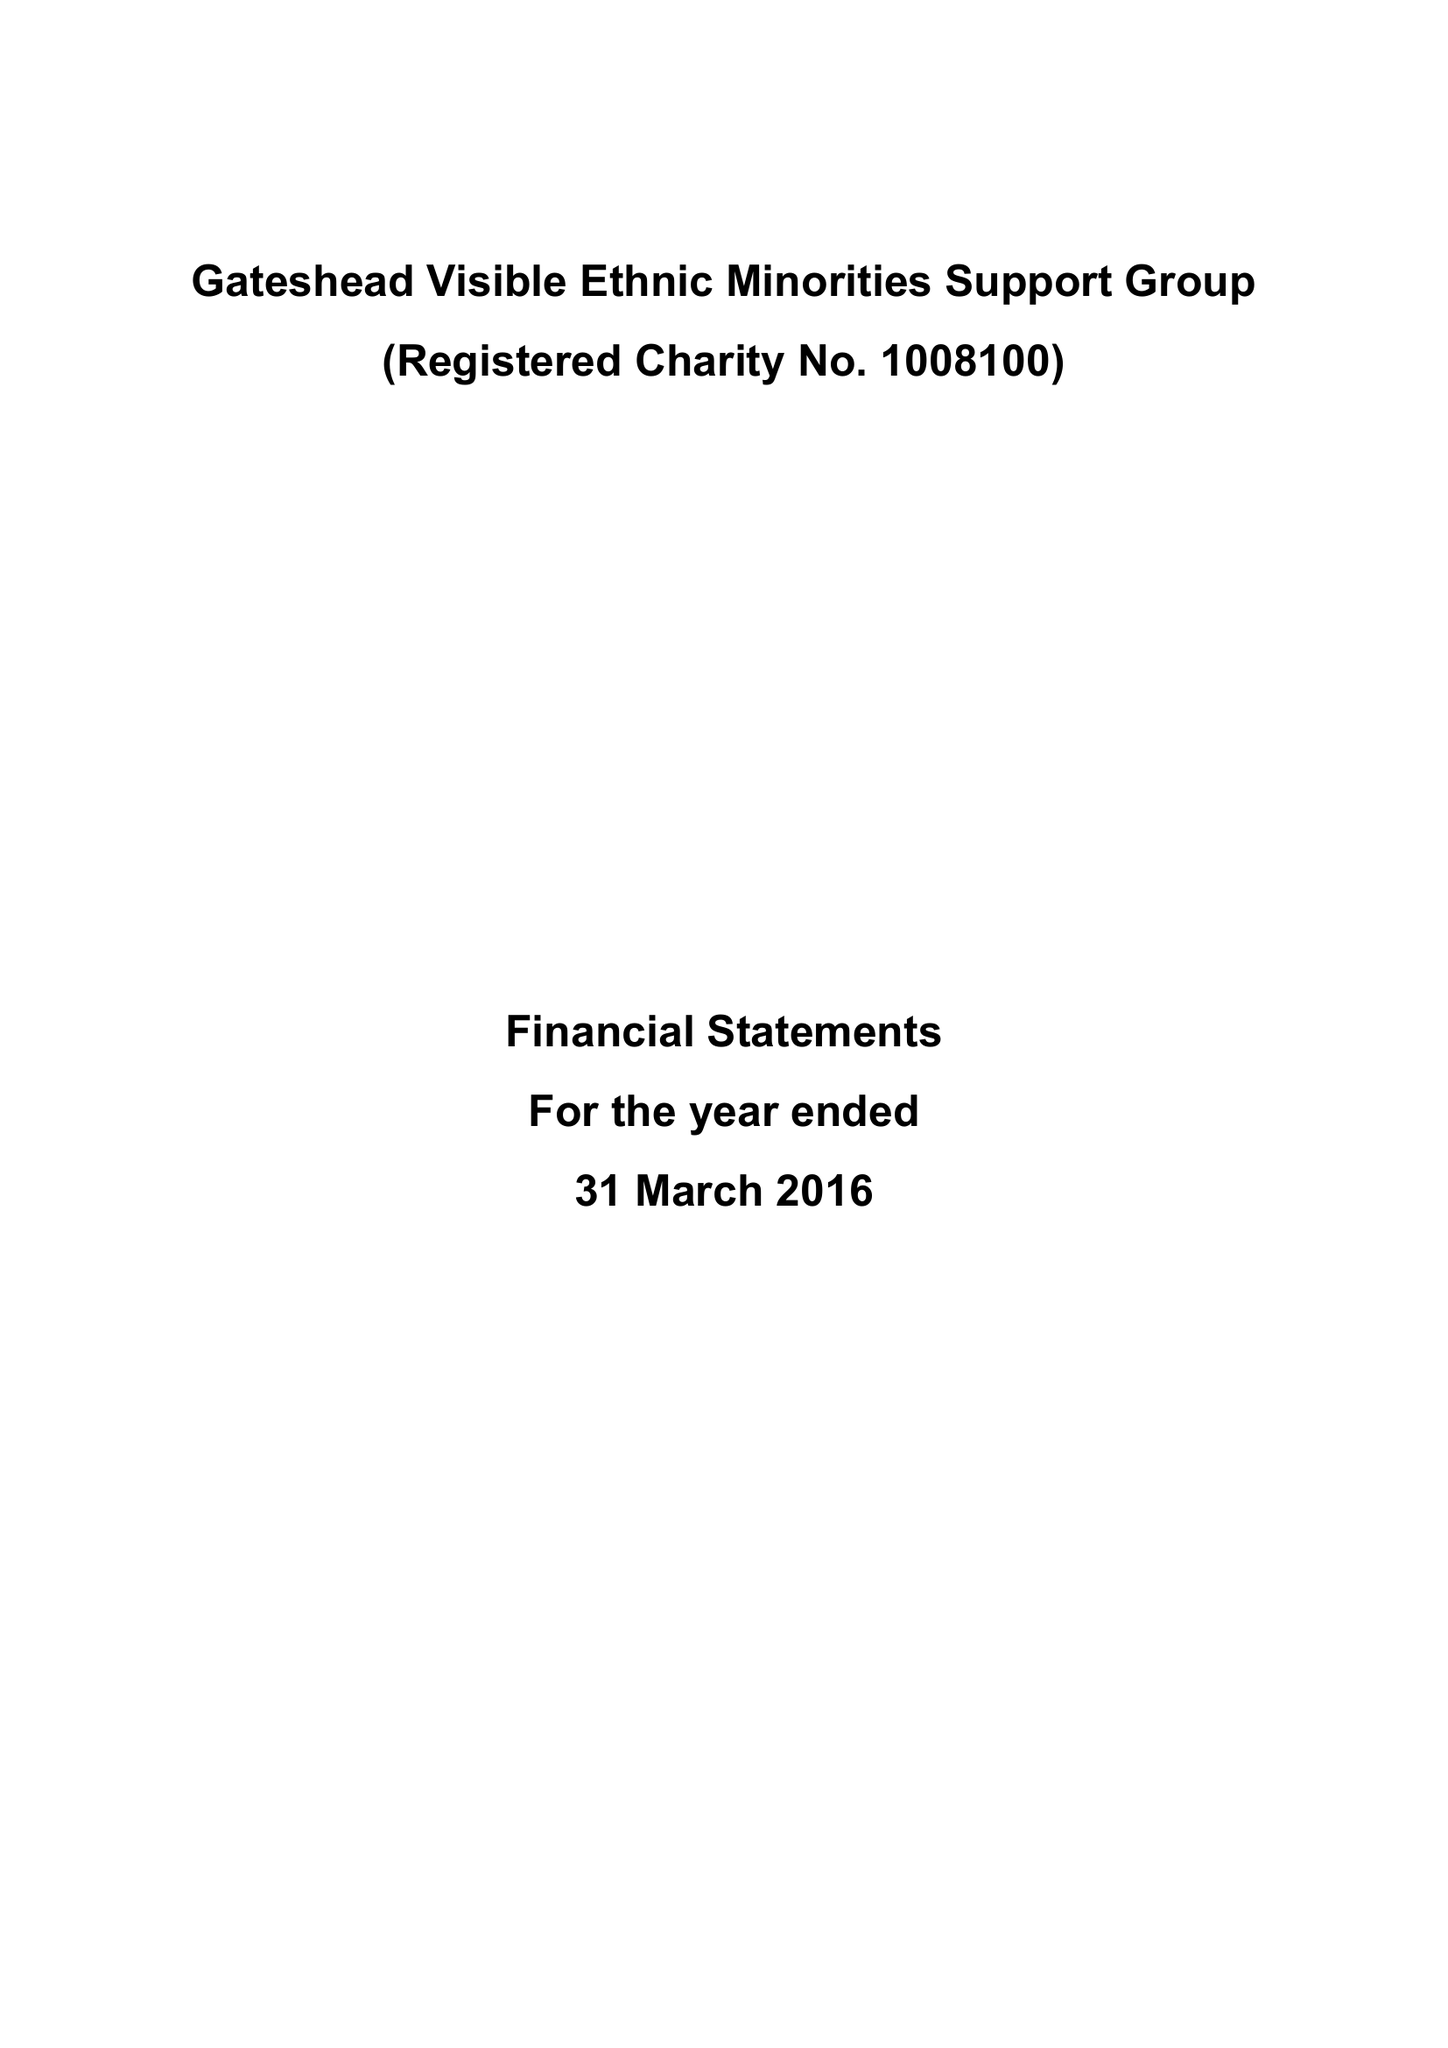What is the value for the address__postcode?
Answer the question using a single word or phrase. NE11 9TT 